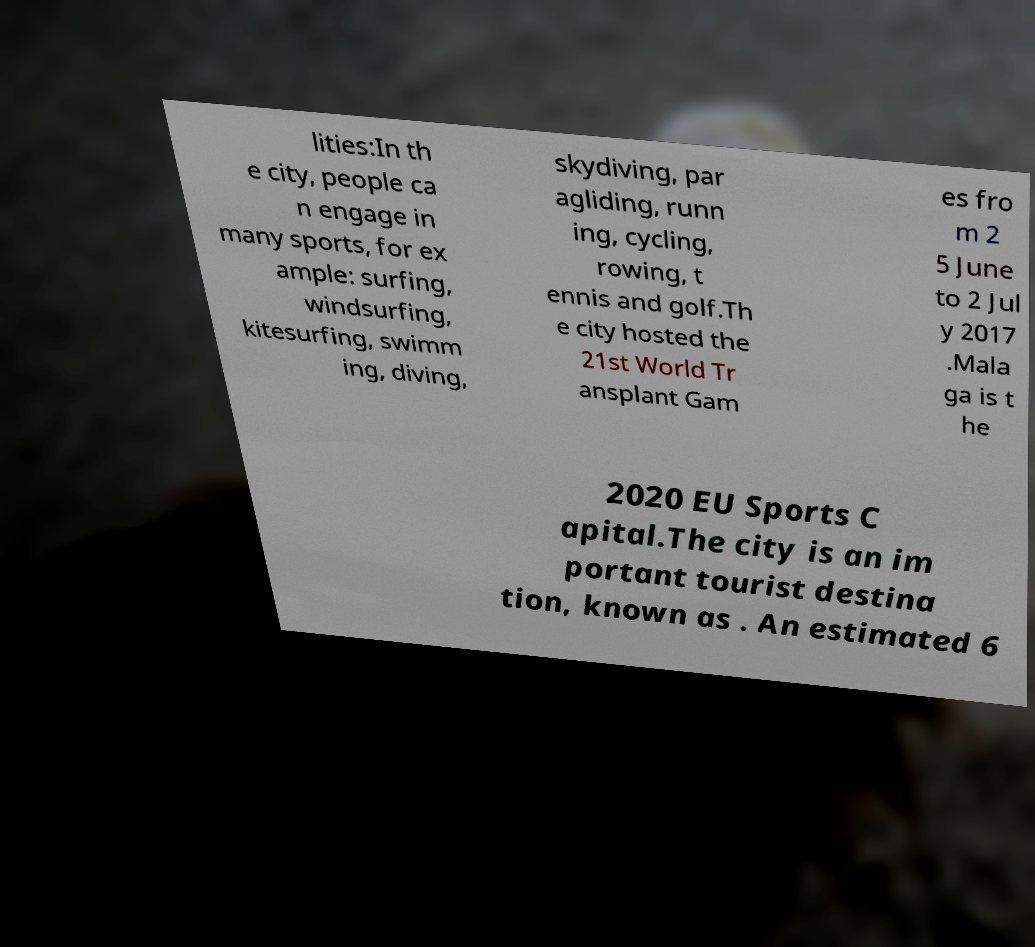Could you extract and type out the text from this image? lities:In th e city, people ca n engage in many sports, for ex ample: surfing, windsurfing, kitesurfing, swimm ing, diving, skydiving, par agliding, runn ing, cycling, rowing, t ennis and golf.Th e city hosted the 21st World Tr ansplant Gam es fro m 2 5 June to 2 Jul y 2017 .Mala ga is t he 2020 EU Sports C apital.The city is an im portant tourist destina tion, known as . An estimated 6 